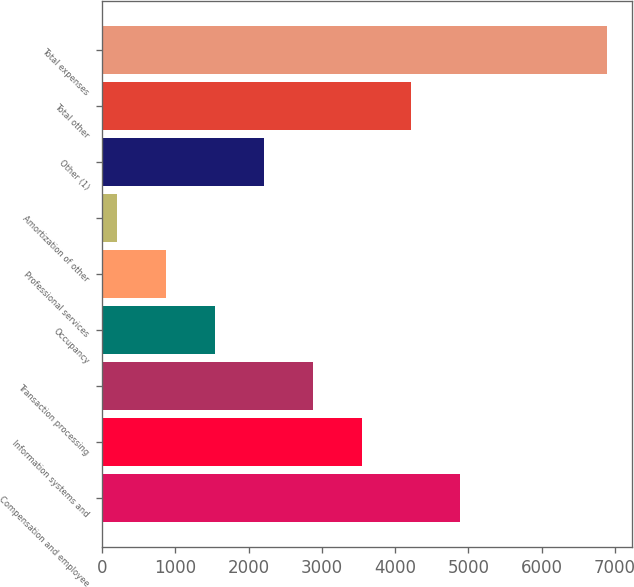Convert chart to OTSL. <chart><loc_0><loc_0><loc_500><loc_500><bar_chart><fcel>Compensation and employee<fcel>Information systems and<fcel>Transaction processing<fcel>Occupancy<fcel>Professional services<fcel>Amortization of other<fcel>Other (1)<fcel>Total other<fcel>Total expenses<nl><fcel>4879.6<fcel>3542<fcel>2873.2<fcel>1535.6<fcel>866.8<fcel>198<fcel>2204.4<fcel>4210.8<fcel>6886<nl></chart> 